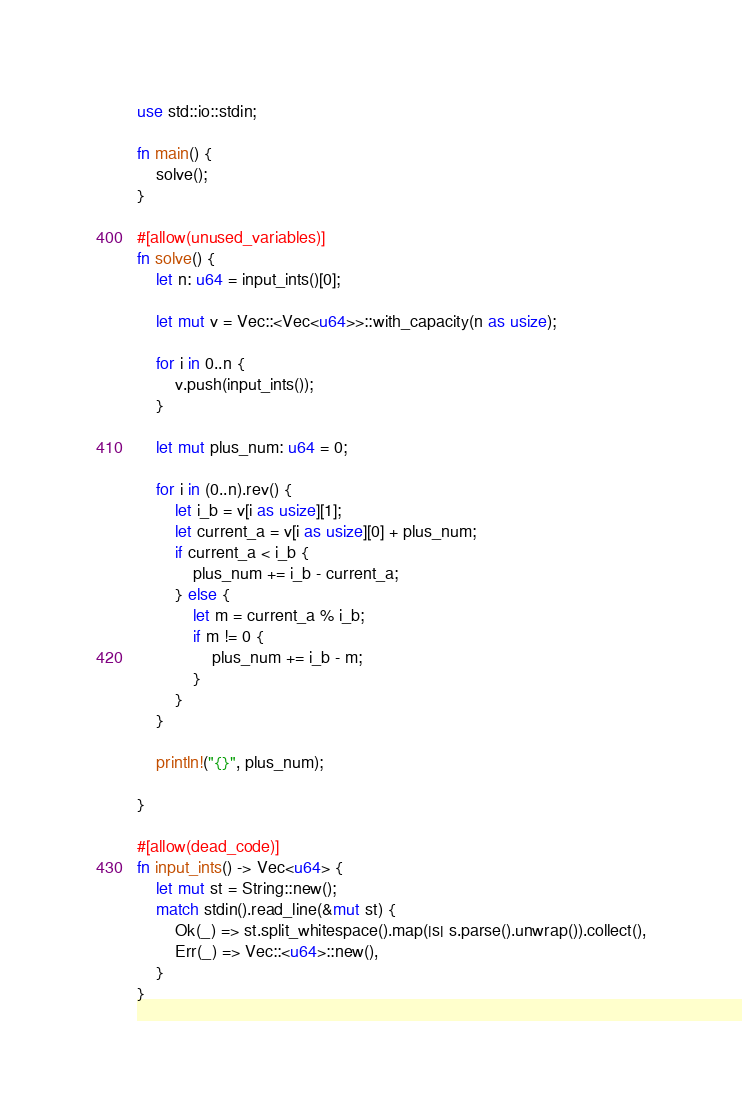Convert code to text. <code><loc_0><loc_0><loc_500><loc_500><_Rust_>use std::io::stdin;

fn main() {
    solve();
}

#[allow(unused_variables)]
fn solve() {
    let n: u64 = input_ints()[0];

    let mut v = Vec::<Vec<u64>>::with_capacity(n as usize);
    
    for i in 0..n {
        v.push(input_ints());
    }

    let mut plus_num: u64 = 0;

    for i in (0..n).rev() {
        let i_b = v[i as usize][1];
        let current_a = v[i as usize][0] + plus_num;
        if current_a < i_b {
            plus_num += i_b - current_a;
        } else {
            let m = current_a % i_b;
            if m != 0 {
                plus_num += i_b - m;
            }
        }
    }

    println!("{}", plus_num);

}

#[allow(dead_code)]
fn input_ints() -> Vec<u64> {
    let mut st = String::new();
    match stdin().read_line(&mut st) {
        Ok(_) => st.split_whitespace().map(|s| s.parse().unwrap()).collect(),
        Err(_) => Vec::<u64>::new(),
    }
}

</code> 